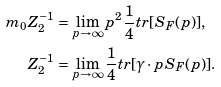<formula> <loc_0><loc_0><loc_500><loc_500>m _ { 0 } Z _ { 2 } ^ { - 1 } & = \lim _ { p \rightarrow \infty } p ^ { 2 } \frac { 1 } { 4 } t r [ S _ { F } ( p ) ] , \\ Z _ { 2 } ^ { - 1 } & = \lim _ { p \rightarrow \infty } \frac { 1 } { 4 } t r [ \gamma \cdot p S _ { F } ( p ) ] .</formula> 